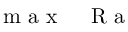<formula> <loc_0><loc_0><loc_500><loc_500>m a x \, { R a }</formula> 